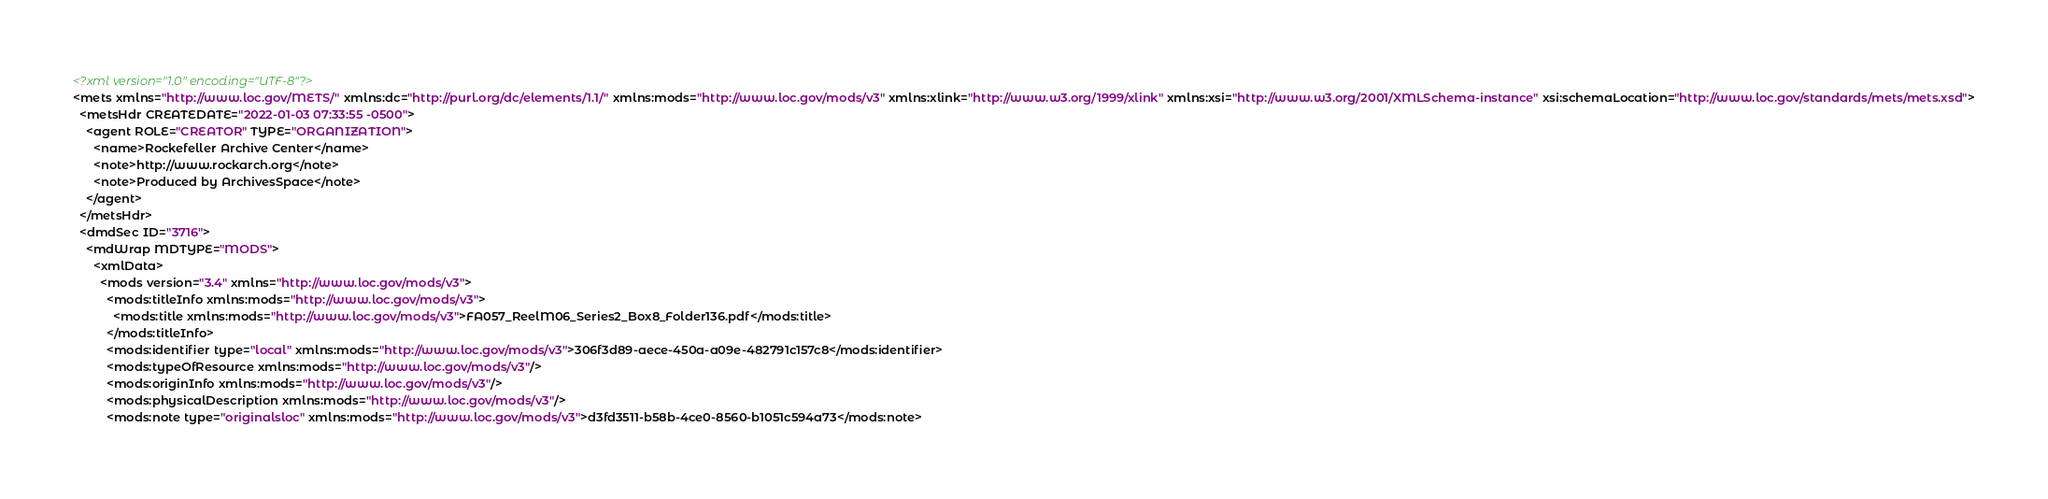Convert code to text. <code><loc_0><loc_0><loc_500><loc_500><_XML_><?xml version="1.0" encoding="UTF-8"?>
<mets xmlns="http://www.loc.gov/METS/" xmlns:dc="http://purl.org/dc/elements/1.1/" xmlns:mods="http://www.loc.gov/mods/v3" xmlns:xlink="http://www.w3.org/1999/xlink" xmlns:xsi="http://www.w3.org/2001/XMLSchema-instance" xsi:schemaLocation="http://www.loc.gov/standards/mets/mets.xsd">
  <metsHdr CREATEDATE="2022-01-03 07:33:55 -0500">
    <agent ROLE="CREATOR" TYPE="ORGANIZATION">
      <name>Rockefeller Archive Center</name>
      <note>http://www.rockarch.org</note>
      <note>Produced by ArchivesSpace</note>
    </agent>
  </metsHdr>
  <dmdSec ID="3716">
    <mdWrap MDTYPE="MODS">
      <xmlData>
        <mods version="3.4" xmlns="http://www.loc.gov/mods/v3">
          <mods:titleInfo xmlns:mods="http://www.loc.gov/mods/v3">
            <mods:title xmlns:mods="http://www.loc.gov/mods/v3">FA057_ReelM06_Series2_Box8_Folder136.pdf</mods:title>
          </mods:titleInfo>
          <mods:identifier type="local" xmlns:mods="http://www.loc.gov/mods/v3">306f3d89-aece-450a-a09e-482791c157c8</mods:identifier>
          <mods:typeOfResource xmlns:mods="http://www.loc.gov/mods/v3"/>
          <mods:originInfo xmlns:mods="http://www.loc.gov/mods/v3"/>
          <mods:physicalDescription xmlns:mods="http://www.loc.gov/mods/v3"/>
          <mods:note type="originalsloc" xmlns:mods="http://www.loc.gov/mods/v3">d3fd3511-b58b-4ce0-8560-b1051c594a73</mods:note></code> 